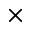<formula> <loc_0><loc_0><loc_500><loc_500>\times</formula> 